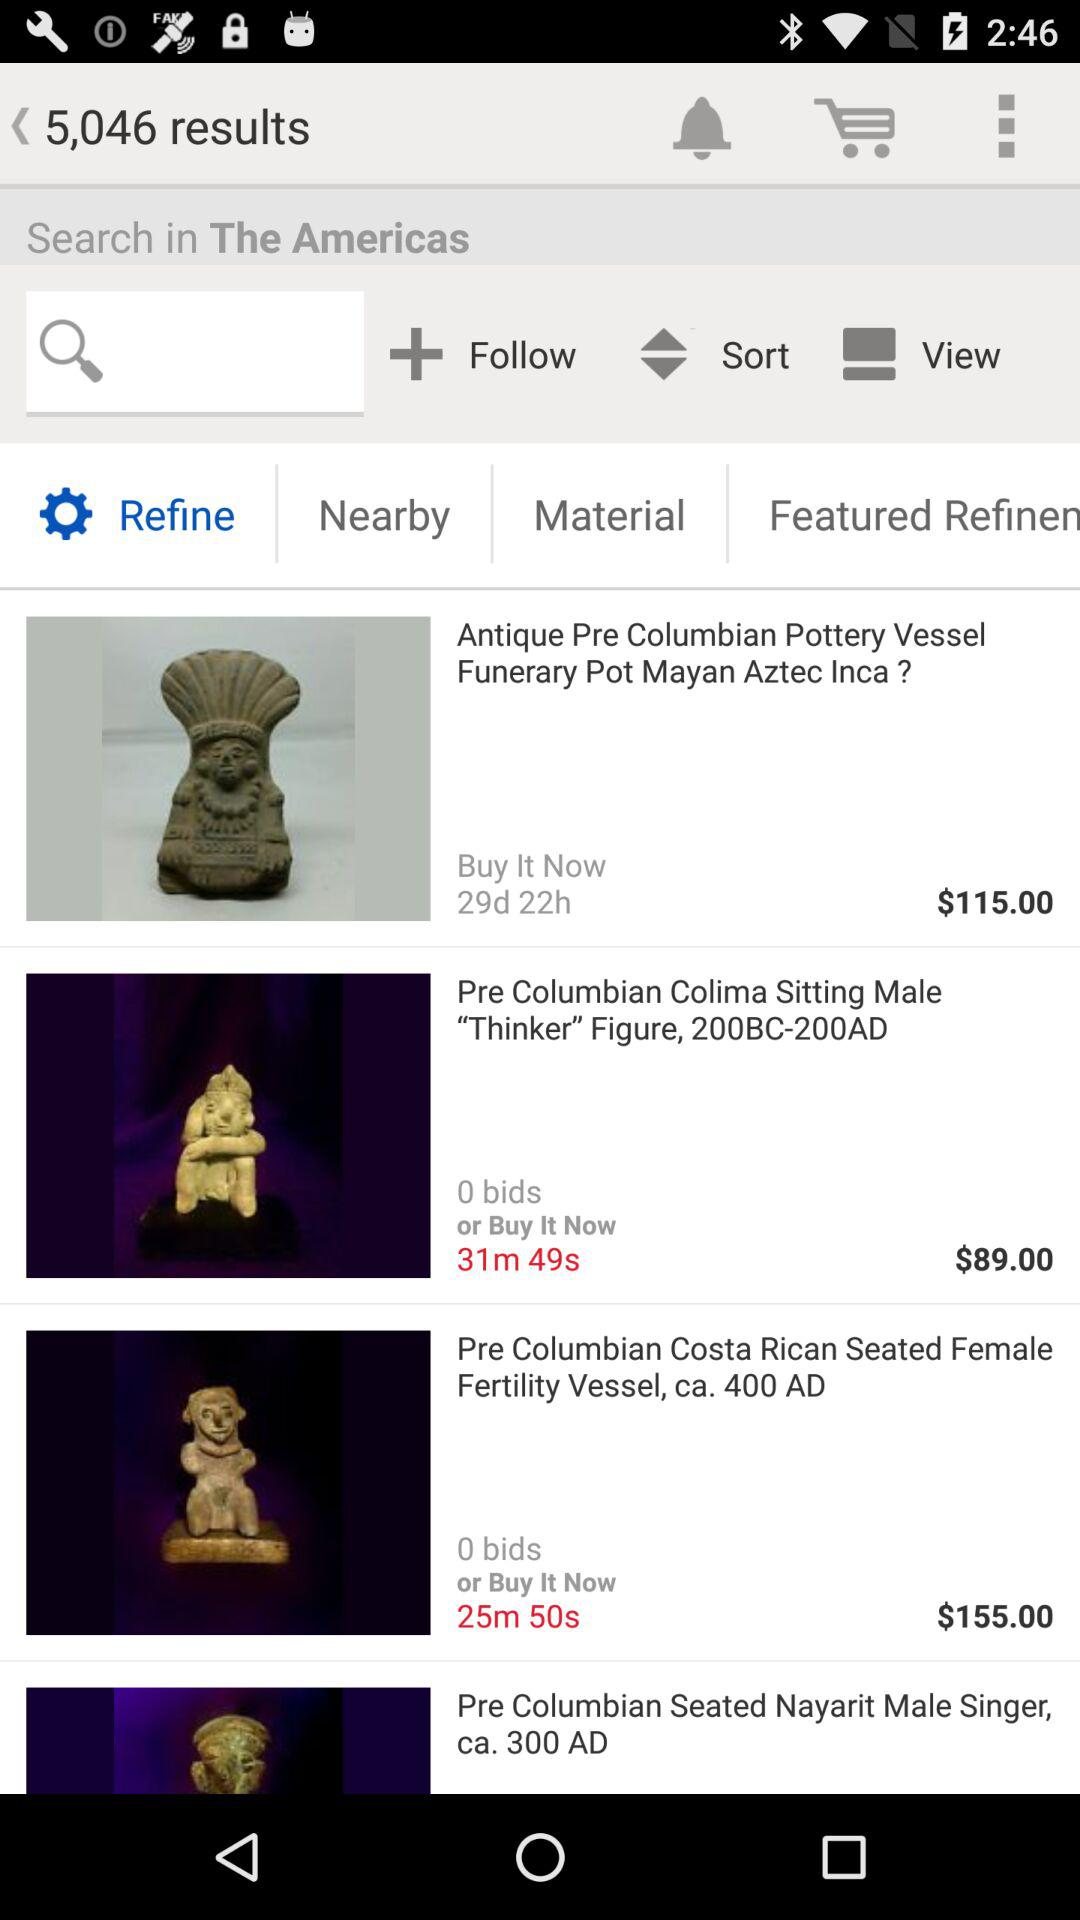What is the price of "Antique Pre Columbian Pottery Vessel"? The price of "Antique Pre Columbian Pottery Vessel" is $115. 